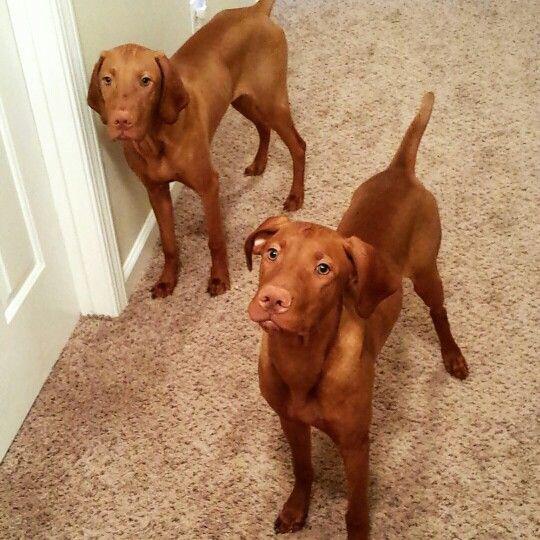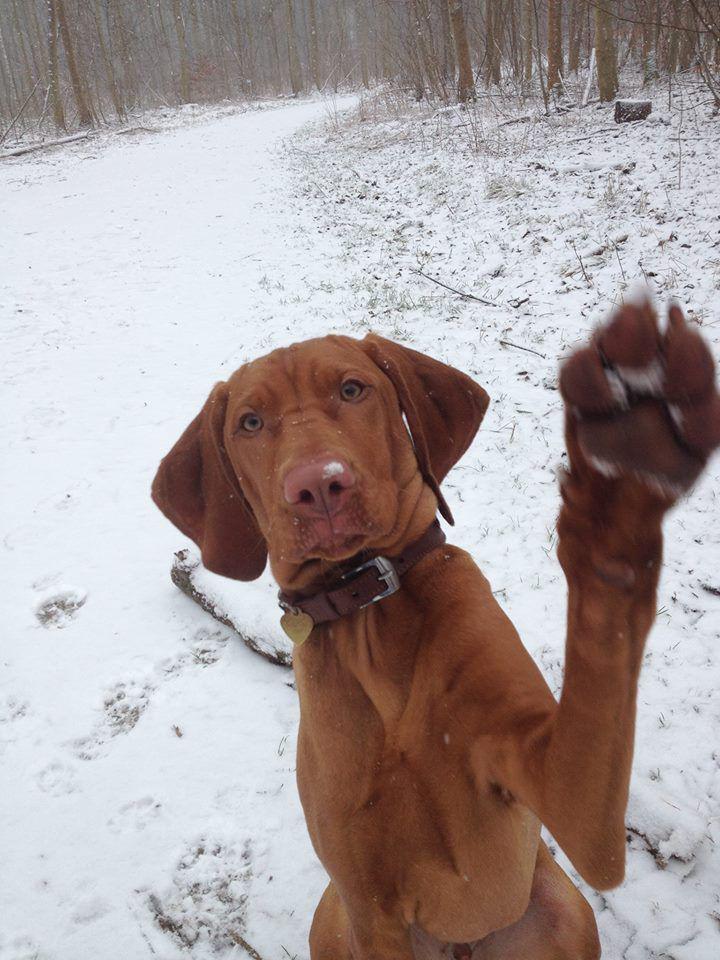The first image is the image on the left, the second image is the image on the right. Evaluate the accuracy of this statement regarding the images: "Each image contains only one dog, the left image features a dog turned forward and sitting upright, and the right image features a rightward-turned dog wearing a collar.". Is it true? Answer yes or no. No. The first image is the image on the left, the second image is the image on the right. Given the left and right images, does the statement "A single dog in the image on the left is sitting up." hold true? Answer yes or no. No. 